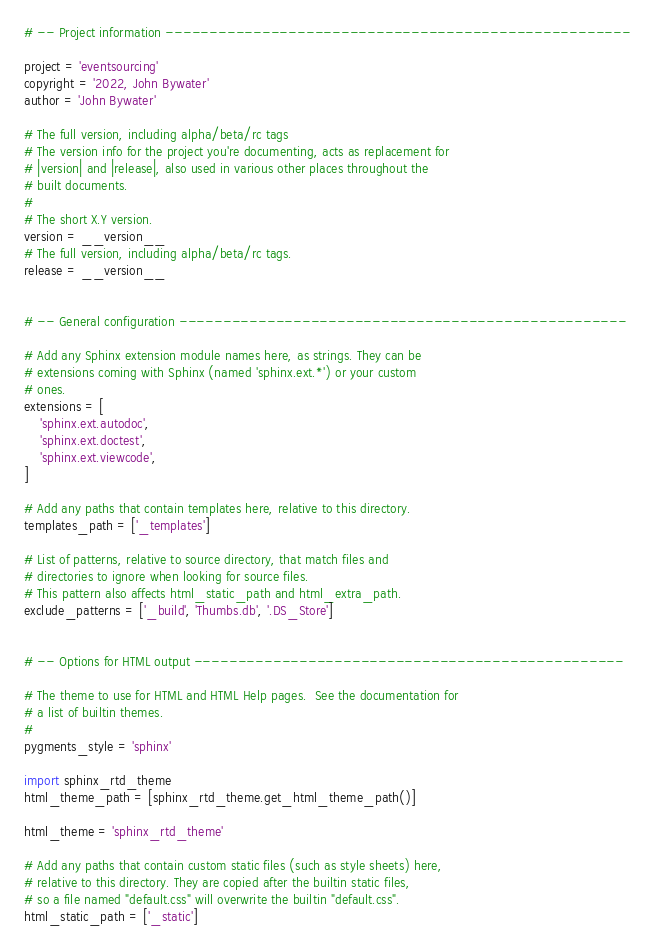<code> <loc_0><loc_0><loc_500><loc_500><_Python_>
# -- Project information -----------------------------------------------------

project = 'eventsourcing'
copyright = '2022, John Bywater'
author = 'John Bywater'

# The full version, including alpha/beta/rc tags
# The version info for the project you're documenting, acts as replacement for
# |version| and |release|, also used in various other places throughout the
# built documents.
#
# The short X.Y version.
version = __version__
# The full version, including alpha/beta/rc tags.
release = __version__


# -- General configuration ---------------------------------------------------

# Add any Sphinx extension module names here, as strings. They can be
# extensions coming with Sphinx (named 'sphinx.ext.*') or your custom
# ones.
extensions = [
    'sphinx.ext.autodoc',
    'sphinx.ext.doctest',
    'sphinx.ext.viewcode',
]

# Add any paths that contain templates here, relative to this directory.
templates_path = ['_templates']

# List of patterns, relative to source directory, that match files and
# directories to ignore when looking for source files.
# This pattern also affects html_static_path and html_extra_path.
exclude_patterns = ['_build', 'Thumbs.db', '.DS_Store']


# -- Options for HTML output -------------------------------------------------

# The theme to use for HTML and HTML Help pages.  See the documentation for
# a list of builtin themes.
#
pygments_style = 'sphinx'

import sphinx_rtd_theme
html_theme_path = [sphinx_rtd_theme.get_html_theme_path()]

html_theme = 'sphinx_rtd_theme'

# Add any paths that contain custom static files (such as style sheets) here,
# relative to this directory. They are copied after the builtin static files,
# so a file named "default.css" will overwrite the builtin "default.css".
html_static_path = ['_static']
</code> 